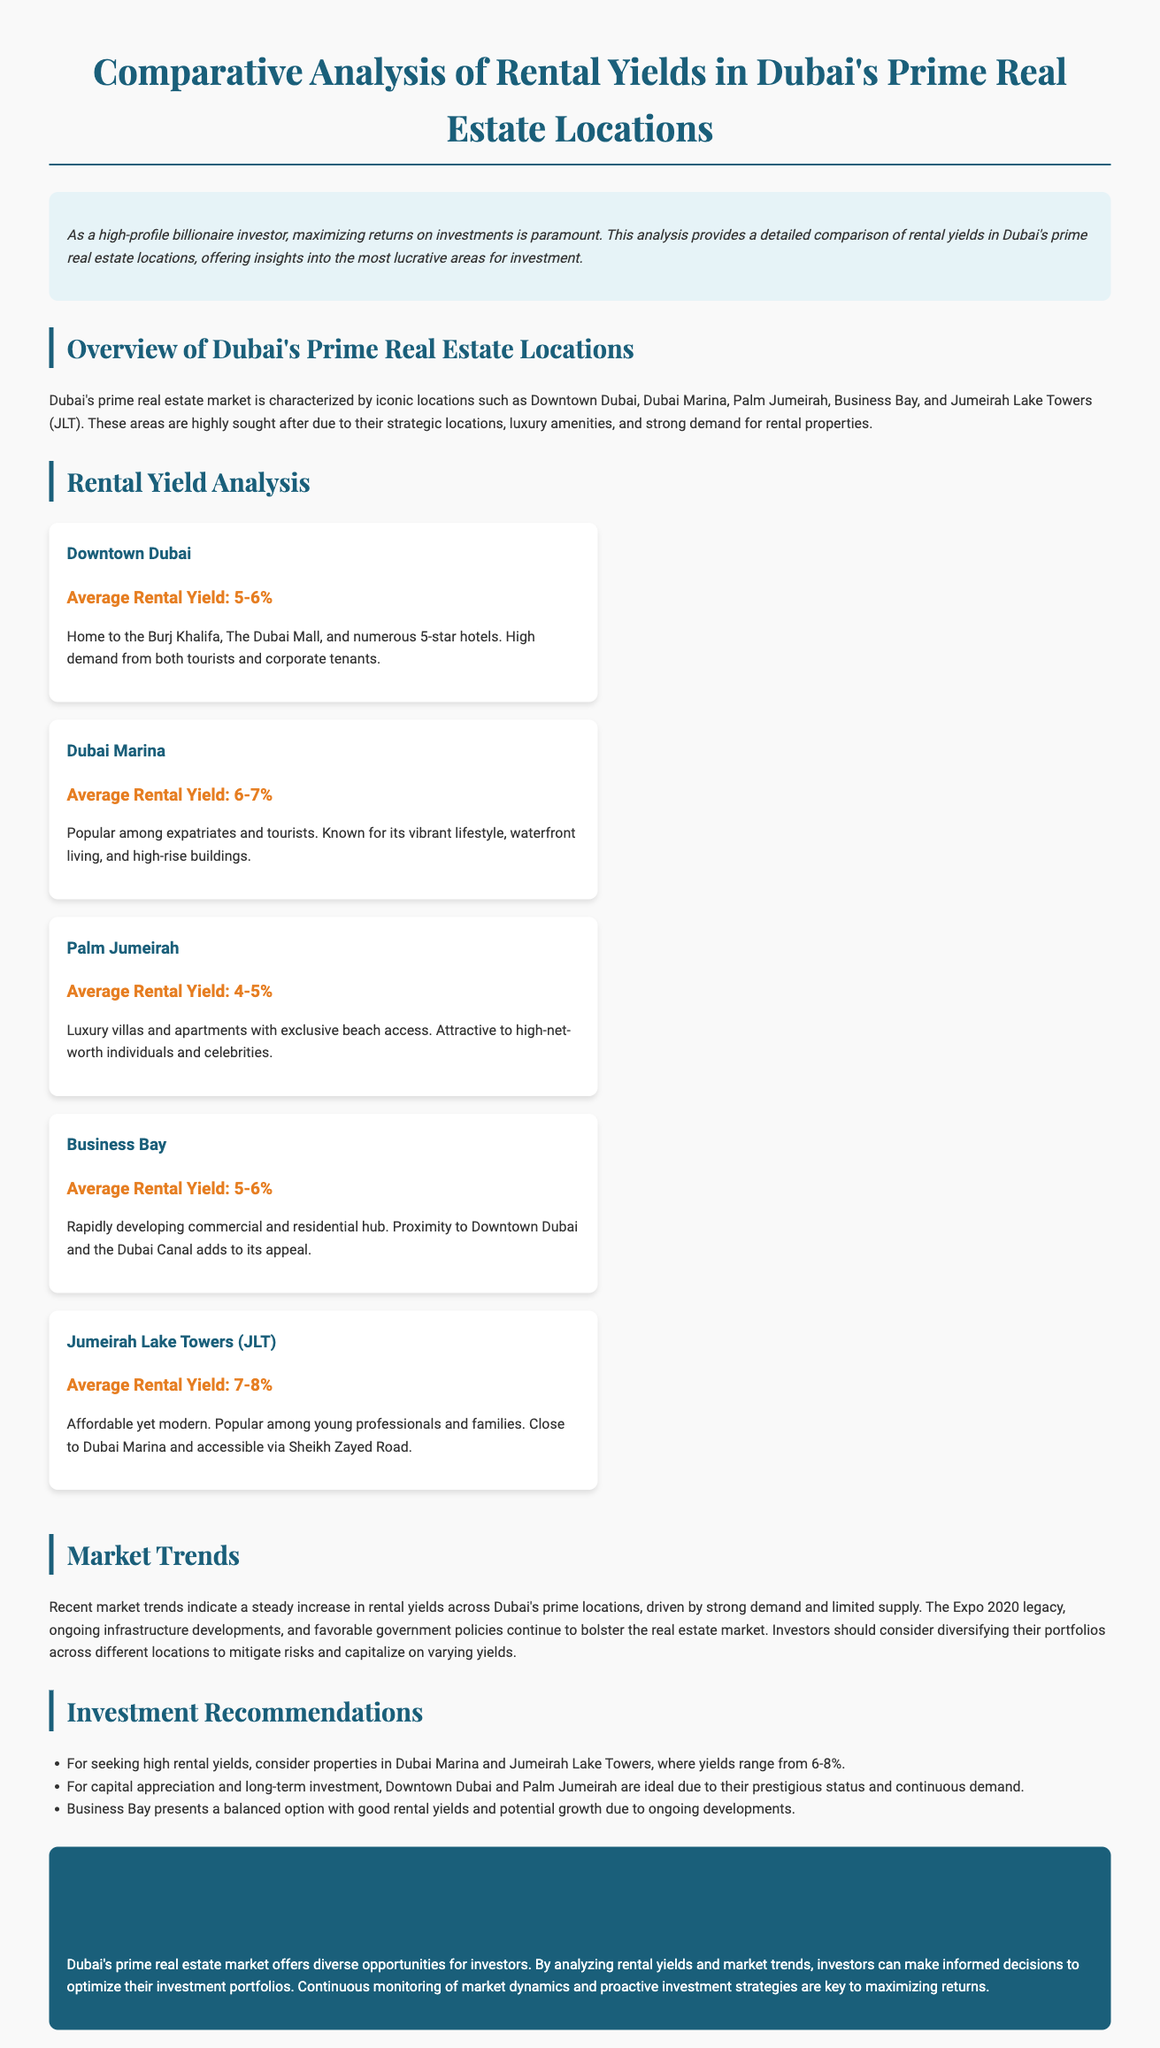What is the average rental yield for Downtown Dubai? The average rental yield for Downtown Dubai is specified in the document.
Answer: 5-6% Which location has the highest average rental yield? The document compares rental yields across various locations, indicating which one has the highest yield.
Answer: Jumeirah Lake Towers What recommendations are made for seeking high rental yields? The document provides recommendations for investors seeking high rental yields based on the analysis.
Answer: Dubai Marina and Jumeirah Lake Towers What is the average rental yield for Palm Jumeirah? This statistic can be found in the analysis section of the document.
Answer: 4-5% Which prime location is mentioned as a popular choice among young professionals? The document discusses different locations and their demographics, indicating what attracts young professionals.
Answer: Jumeirah Lake Towers What factor is driving the increase in rental yields? The document outlines various factors contributing to market trends in rental yields.
Answer: Strong demand and limited supply How many prime real estate locations are discussed in the document? The number of locations analyzed in the rental yield section can be counted from the document.
Answer: Five What is mentioned as a significant ongoing development in Dubai? The document refers to specific events that have impacted the real estate market's growth.
Answer: Expo 2020 legacy Which area is described as attractive to high-net-worth individuals? The document classifies each location with specific characteristics appealing to different demographics.
Answer: Palm Jumeirah 